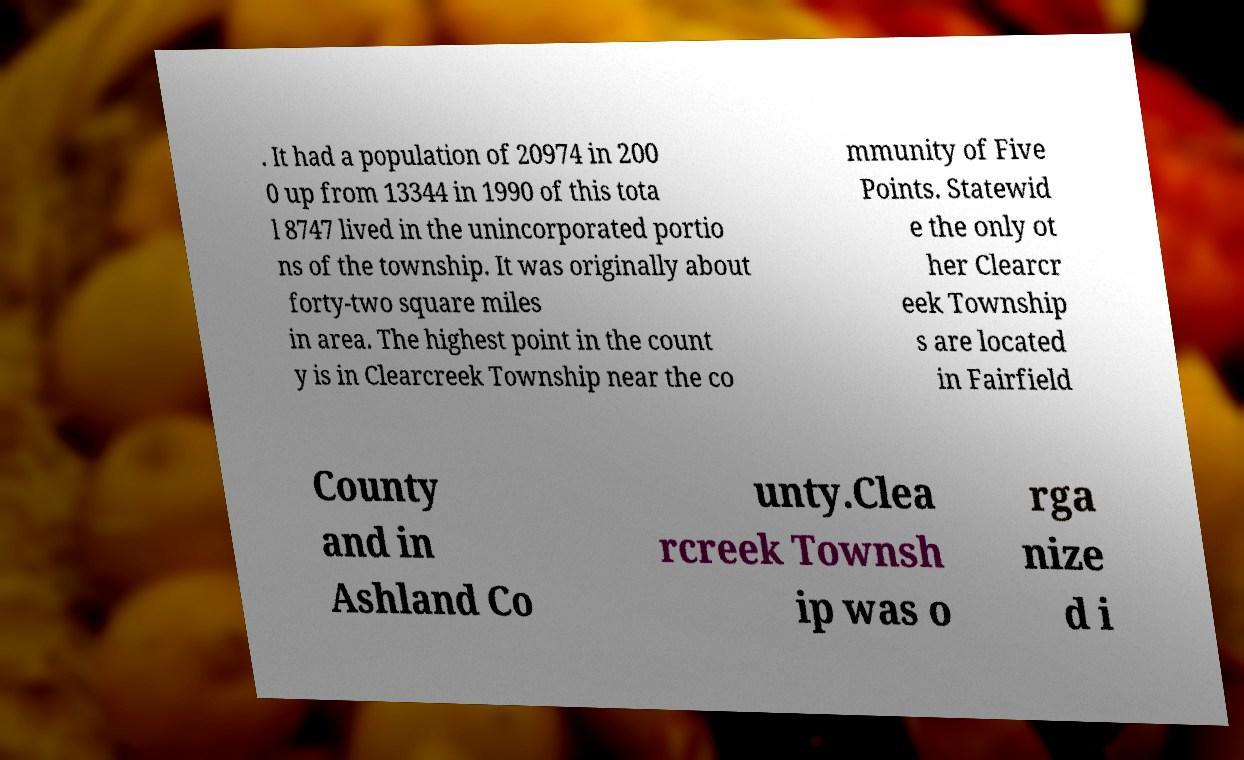Could you assist in decoding the text presented in this image and type it out clearly? . It had a population of 20974 in 200 0 up from 13344 in 1990 of this tota l 8747 lived in the unincorporated portio ns of the township. It was originally about forty-two square miles in area. The highest point in the count y is in Clearcreek Township near the co mmunity of Five Points. Statewid e the only ot her Clearcr eek Township s are located in Fairfield County and in Ashland Co unty.Clea rcreek Townsh ip was o rga nize d i 